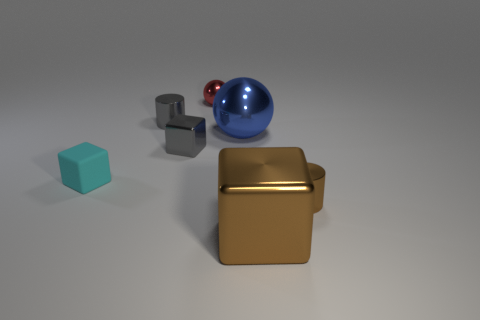Is the number of things that are to the right of the tiny cyan matte thing the same as the number of things behind the big brown shiny thing?
Keep it short and to the point. Yes. Are there more big blue spheres than large brown matte blocks?
Offer a terse response. Yes. What number of shiny things are either brown blocks or blue cylinders?
Provide a short and direct response. 1. What number of other matte objects have the same color as the tiny matte thing?
Provide a succinct answer. 0. There is a large thing in front of the large object behind the tiny cylinder in front of the cyan thing; what is it made of?
Provide a short and direct response. Metal. The tiny cylinder that is left of the large object in front of the cyan object is what color?
Give a very brief answer. Gray. How many large objects are gray metallic things or matte blocks?
Your response must be concise. 0. What number of small cubes are the same material as the big block?
Keep it short and to the point. 1. There is a cylinder that is on the right side of the gray metal cylinder; what size is it?
Your answer should be very brief. Small. There is a tiny gray metal thing that is right of the cylinder behind the small brown metal cylinder; what shape is it?
Offer a terse response. Cube. 